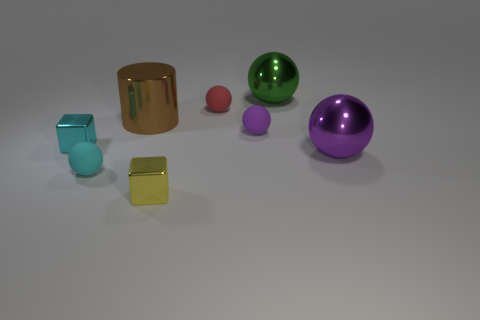Subtract all purple balls. How many balls are left? 3 Subtract all purple matte balls. How many balls are left? 4 Subtract all brown balls. Subtract all brown cylinders. How many balls are left? 5 Add 1 cylinders. How many objects exist? 9 Subtract all cubes. How many objects are left? 6 Subtract 0 blue balls. How many objects are left? 8 Subtract all small brown metal balls. Subtract all cyan balls. How many objects are left? 7 Add 8 metal spheres. How many metal spheres are left? 10 Add 7 rubber balls. How many rubber balls exist? 10 